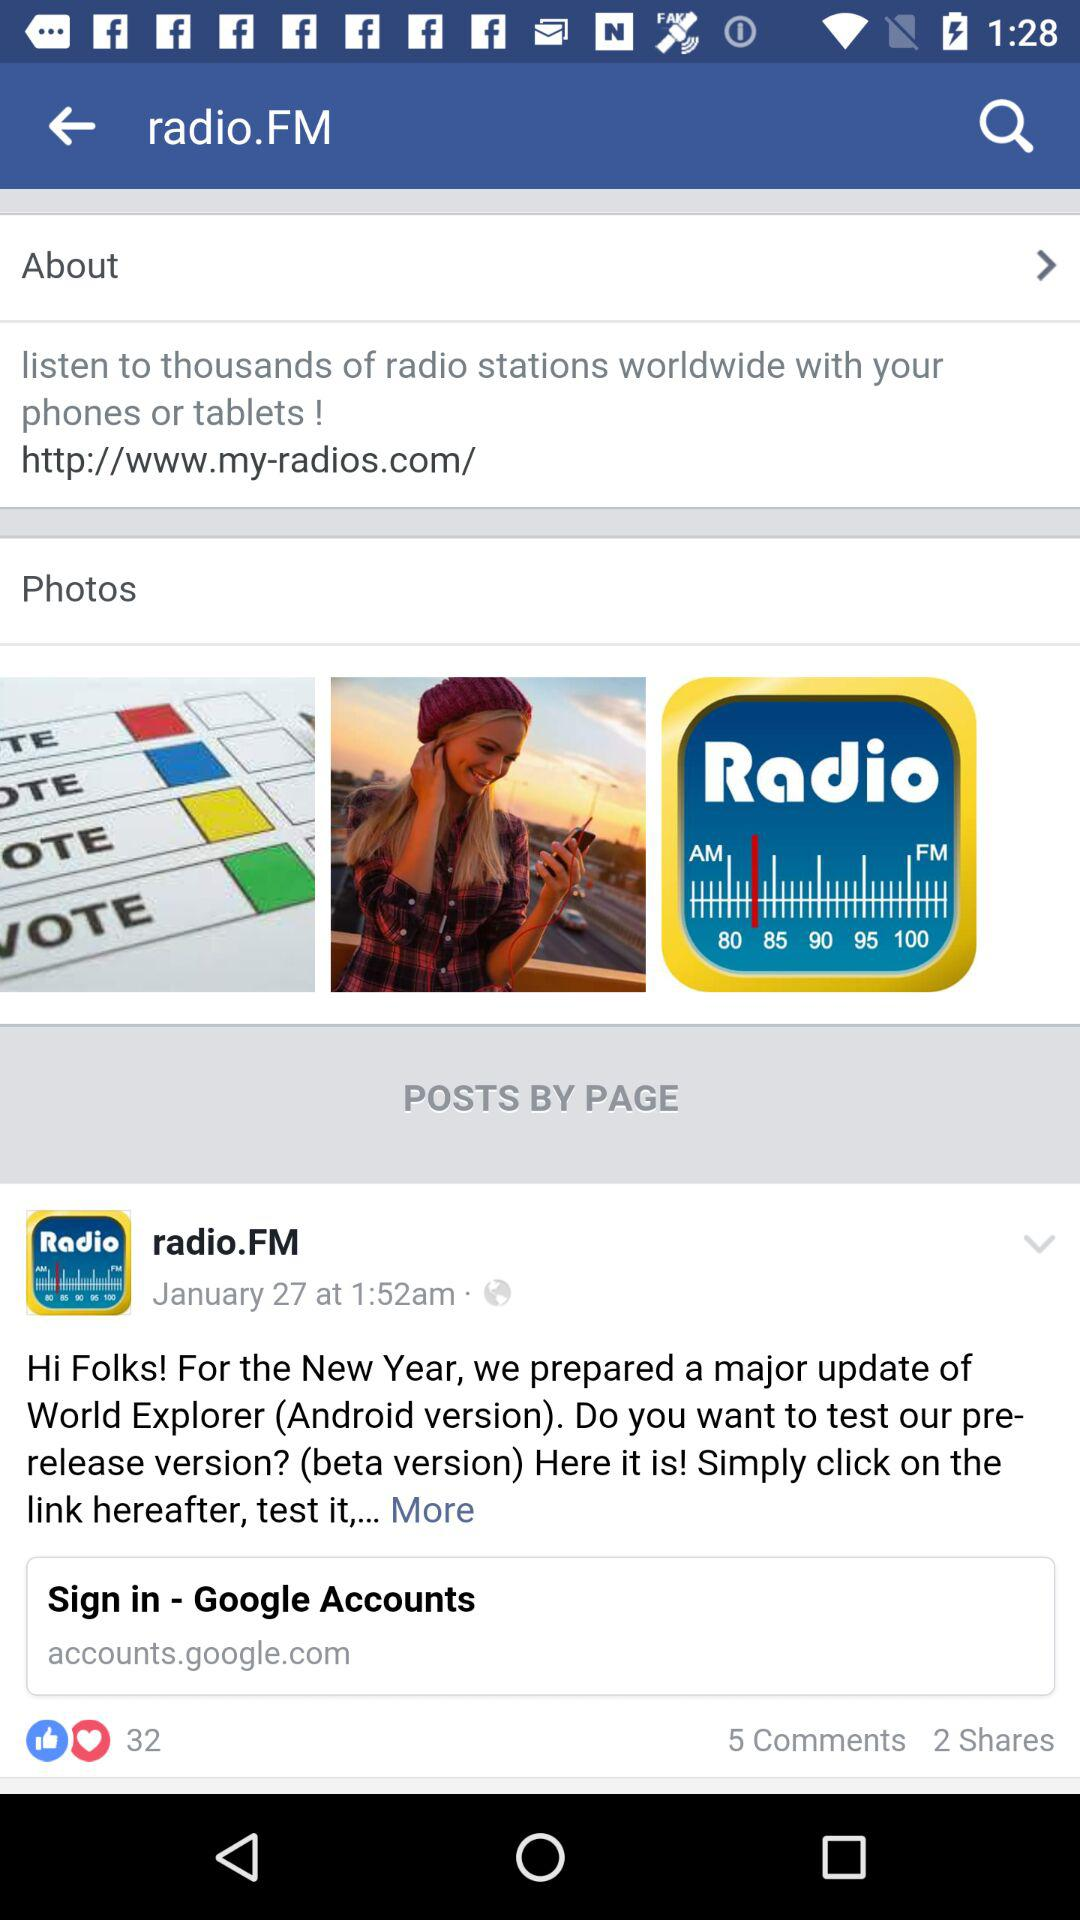How many shares are there? There are 2 shares. 